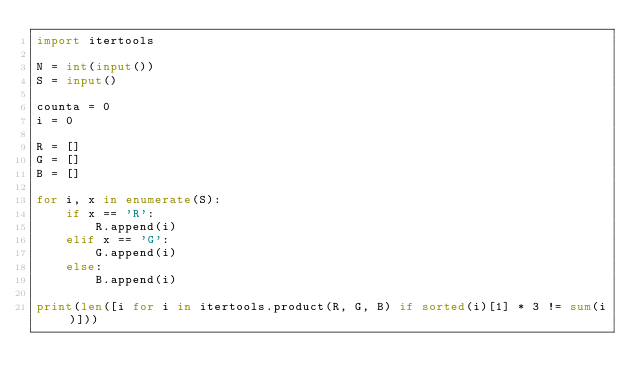Convert code to text. <code><loc_0><loc_0><loc_500><loc_500><_Python_>import itertools

N = int(input())
S = input()

counta = 0
i = 0

R = []
G = []
B = []

for i, x in enumerate(S):
    if x == 'R':
        R.append(i)
    elif x == 'G':
        G.append(i)
    else:
        B.append(i)

print(len([i for i in itertools.product(R, G, B) if sorted(i)[1] * 3 != sum(i)]))</code> 